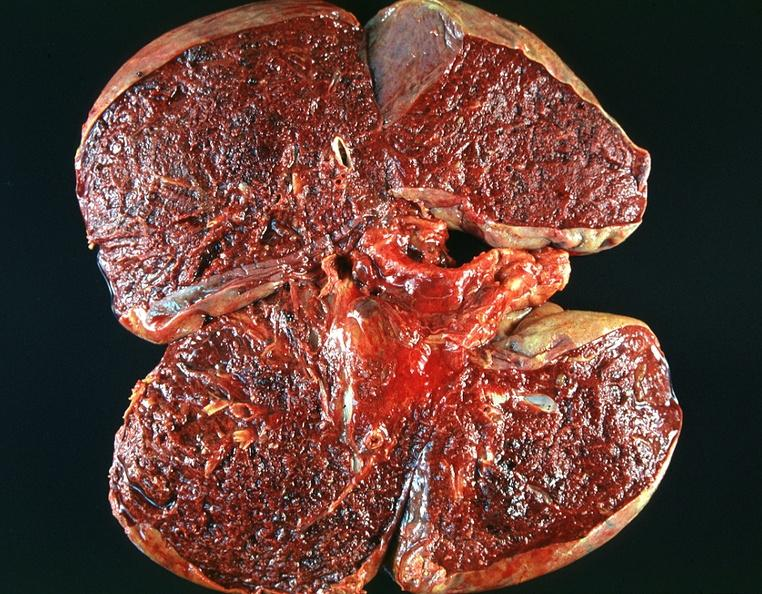s wonder present?
Answer the question using a single word or phrase. No 